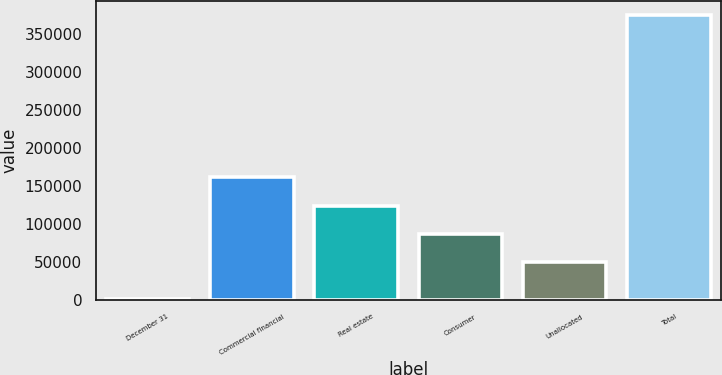<chart> <loc_0><loc_0><loc_500><loc_500><bar_chart><fcel>December 31<fcel>Commercial financial<fcel>Real estate<fcel>Consumer<fcel>Unallocated<fcel>Total<nl><fcel>2000<fcel>161889<fcel>124619<fcel>87348.3<fcel>50078<fcel>374703<nl></chart> 